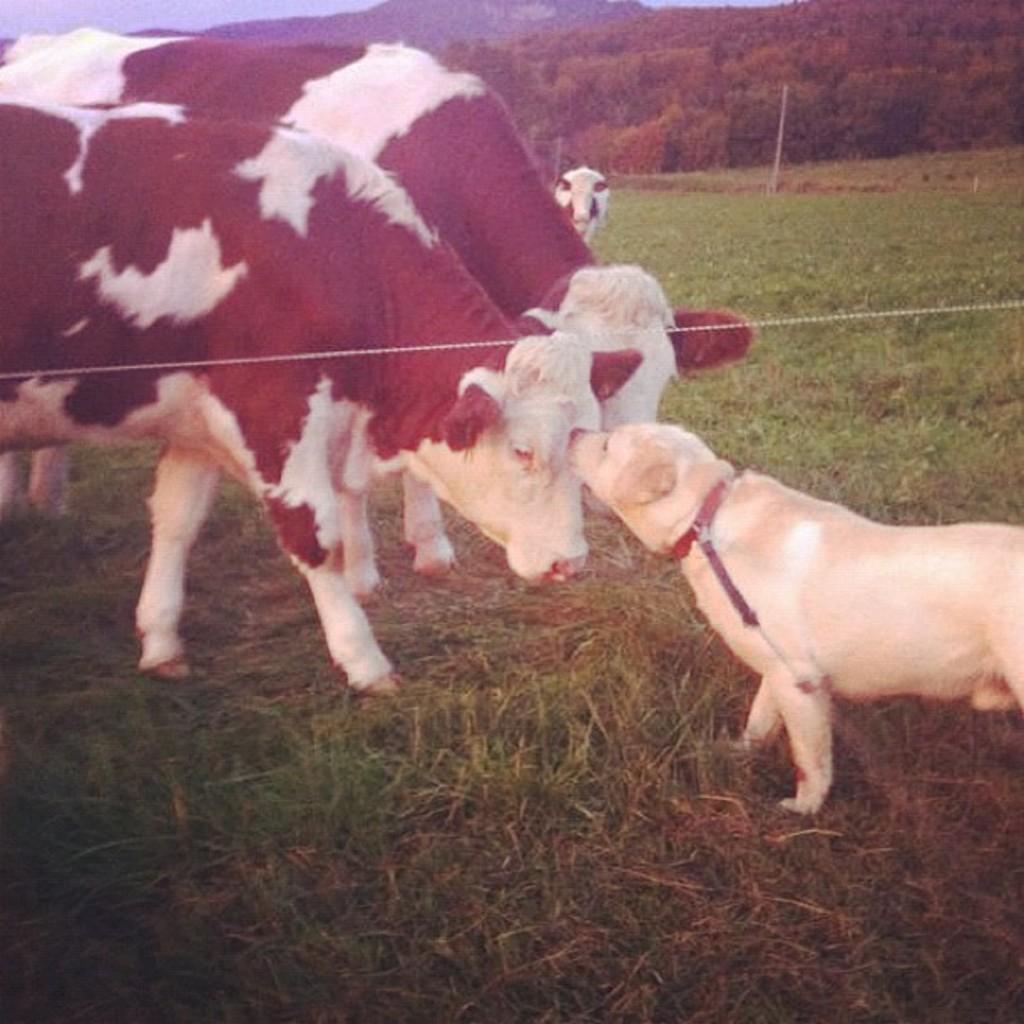How would you summarize this image in a sentence or two? In this image I can see few animals in cream, white and black color. Background I can see few plants and trees in green color and the sky is in blue color. 